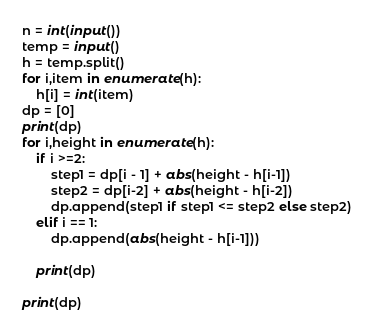<code> <loc_0><loc_0><loc_500><loc_500><_Python_>
n = int(input())
temp = input()
h = temp.split()
for i,item in enumerate(h):
    h[i] = int(item)
dp = [0]
print(dp)
for i,height in enumerate(h):
    if i >=2:
        step1 = dp[i - 1] + abs(height - h[i-1])
        step2 = dp[i-2] + abs(height - h[i-2])
        dp.append(step1 if step1 <= step2 else step2)
    elif i == 1:
        dp.append(abs(height - h[i-1]))

    print(dp)

print(dp)


</code> 